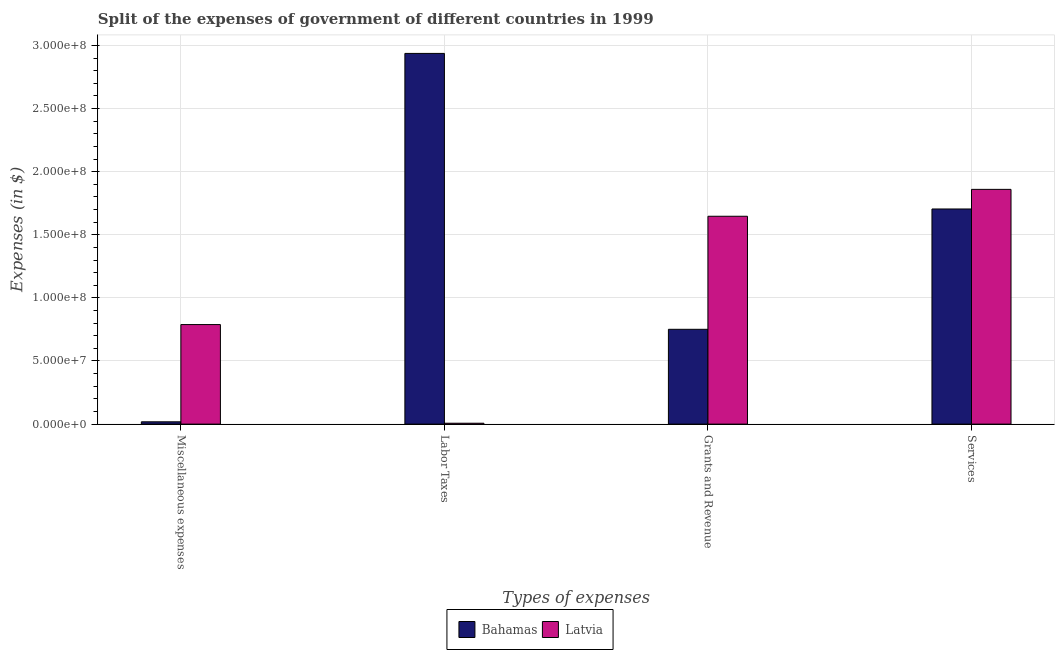How many groups of bars are there?
Ensure brevity in your answer.  4. Are the number of bars per tick equal to the number of legend labels?
Provide a short and direct response. Yes. What is the label of the 3rd group of bars from the left?
Provide a short and direct response. Grants and Revenue. What is the amount spent on labor taxes in Latvia?
Provide a succinct answer. 7.00e+05. Across all countries, what is the maximum amount spent on labor taxes?
Provide a short and direct response. 2.94e+08. Across all countries, what is the minimum amount spent on services?
Offer a very short reply. 1.70e+08. In which country was the amount spent on grants and revenue maximum?
Ensure brevity in your answer.  Latvia. In which country was the amount spent on miscellaneous expenses minimum?
Keep it short and to the point. Bahamas. What is the total amount spent on labor taxes in the graph?
Give a very brief answer. 2.94e+08. What is the difference between the amount spent on miscellaneous expenses in Bahamas and that in Latvia?
Provide a succinct answer. -7.70e+07. What is the difference between the amount spent on miscellaneous expenses in Latvia and the amount spent on labor taxes in Bahamas?
Ensure brevity in your answer.  -2.15e+08. What is the average amount spent on services per country?
Provide a succinct answer. 1.78e+08. What is the difference between the amount spent on miscellaneous expenses and amount spent on services in Latvia?
Your answer should be very brief. -1.07e+08. What is the ratio of the amount spent on grants and revenue in Latvia to that in Bahamas?
Your answer should be compact. 2.19. Is the difference between the amount spent on services in Bahamas and Latvia greater than the difference between the amount spent on grants and revenue in Bahamas and Latvia?
Offer a terse response. Yes. What is the difference between the highest and the second highest amount spent on miscellaneous expenses?
Provide a short and direct response. 7.70e+07. What is the difference between the highest and the lowest amount spent on labor taxes?
Give a very brief answer. 2.93e+08. What does the 1st bar from the left in Miscellaneous expenses represents?
Offer a very short reply. Bahamas. What does the 2nd bar from the right in Labor Taxes represents?
Ensure brevity in your answer.  Bahamas. Is it the case that in every country, the sum of the amount spent on miscellaneous expenses and amount spent on labor taxes is greater than the amount spent on grants and revenue?
Give a very brief answer. No. How many countries are there in the graph?
Provide a succinct answer. 2. Are the values on the major ticks of Y-axis written in scientific E-notation?
Your answer should be compact. Yes. Does the graph contain any zero values?
Your answer should be very brief. No. Does the graph contain grids?
Ensure brevity in your answer.  Yes. Where does the legend appear in the graph?
Ensure brevity in your answer.  Bottom center. How are the legend labels stacked?
Your answer should be compact. Horizontal. What is the title of the graph?
Provide a short and direct response. Split of the expenses of government of different countries in 1999. Does "Canada" appear as one of the legend labels in the graph?
Make the answer very short. No. What is the label or title of the X-axis?
Provide a succinct answer. Types of expenses. What is the label or title of the Y-axis?
Your response must be concise. Expenses (in $). What is the Expenses (in $) in Bahamas in Miscellaneous expenses?
Make the answer very short. 1.83e+06. What is the Expenses (in $) in Latvia in Miscellaneous expenses?
Keep it short and to the point. 7.89e+07. What is the Expenses (in $) in Bahamas in Labor Taxes?
Offer a terse response. 2.94e+08. What is the Expenses (in $) in Bahamas in Grants and Revenue?
Offer a terse response. 7.51e+07. What is the Expenses (in $) in Latvia in Grants and Revenue?
Your response must be concise. 1.65e+08. What is the Expenses (in $) in Bahamas in Services?
Offer a terse response. 1.70e+08. What is the Expenses (in $) of Latvia in Services?
Keep it short and to the point. 1.86e+08. Across all Types of expenses, what is the maximum Expenses (in $) of Bahamas?
Offer a very short reply. 2.94e+08. Across all Types of expenses, what is the maximum Expenses (in $) in Latvia?
Your response must be concise. 1.86e+08. Across all Types of expenses, what is the minimum Expenses (in $) of Bahamas?
Offer a terse response. 1.83e+06. What is the total Expenses (in $) of Bahamas in the graph?
Provide a short and direct response. 5.41e+08. What is the total Expenses (in $) of Latvia in the graph?
Offer a terse response. 4.30e+08. What is the difference between the Expenses (in $) in Bahamas in Miscellaneous expenses and that in Labor Taxes?
Your response must be concise. -2.92e+08. What is the difference between the Expenses (in $) of Latvia in Miscellaneous expenses and that in Labor Taxes?
Make the answer very short. 7.82e+07. What is the difference between the Expenses (in $) in Bahamas in Miscellaneous expenses and that in Grants and Revenue?
Make the answer very short. -7.33e+07. What is the difference between the Expenses (in $) in Latvia in Miscellaneous expenses and that in Grants and Revenue?
Offer a terse response. -8.58e+07. What is the difference between the Expenses (in $) of Bahamas in Miscellaneous expenses and that in Services?
Your response must be concise. -1.69e+08. What is the difference between the Expenses (in $) of Latvia in Miscellaneous expenses and that in Services?
Ensure brevity in your answer.  -1.07e+08. What is the difference between the Expenses (in $) in Bahamas in Labor Taxes and that in Grants and Revenue?
Your answer should be compact. 2.19e+08. What is the difference between the Expenses (in $) in Latvia in Labor Taxes and that in Grants and Revenue?
Offer a terse response. -1.64e+08. What is the difference between the Expenses (in $) in Bahamas in Labor Taxes and that in Services?
Your answer should be compact. 1.23e+08. What is the difference between the Expenses (in $) in Latvia in Labor Taxes and that in Services?
Ensure brevity in your answer.  -1.85e+08. What is the difference between the Expenses (in $) of Bahamas in Grants and Revenue and that in Services?
Provide a succinct answer. -9.53e+07. What is the difference between the Expenses (in $) in Latvia in Grants and Revenue and that in Services?
Your response must be concise. -2.13e+07. What is the difference between the Expenses (in $) in Bahamas in Miscellaneous expenses and the Expenses (in $) in Latvia in Labor Taxes?
Ensure brevity in your answer.  1.13e+06. What is the difference between the Expenses (in $) of Bahamas in Miscellaneous expenses and the Expenses (in $) of Latvia in Grants and Revenue?
Your response must be concise. -1.63e+08. What is the difference between the Expenses (in $) in Bahamas in Miscellaneous expenses and the Expenses (in $) in Latvia in Services?
Your response must be concise. -1.84e+08. What is the difference between the Expenses (in $) of Bahamas in Labor Taxes and the Expenses (in $) of Latvia in Grants and Revenue?
Provide a succinct answer. 1.29e+08. What is the difference between the Expenses (in $) of Bahamas in Labor Taxes and the Expenses (in $) of Latvia in Services?
Make the answer very short. 1.08e+08. What is the difference between the Expenses (in $) of Bahamas in Grants and Revenue and the Expenses (in $) of Latvia in Services?
Your answer should be compact. -1.11e+08. What is the average Expenses (in $) of Bahamas per Types of expenses?
Offer a terse response. 1.35e+08. What is the average Expenses (in $) in Latvia per Types of expenses?
Keep it short and to the point. 1.08e+08. What is the difference between the Expenses (in $) in Bahamas and Expenses (in $) in Latvia in Miscellaneous expenses?
Offer a very short reply. -7.70e+07. What is the difference between the Expenses (in $) in Bahamas and Expenses (in $) in Latvia in Labor Taxes?
Give a very brief answer. 2.93e+08. What is the difference between the Expenses (in $) of Bahamas and Expenses (in $) of Latvia in Grants and Revenue?
Your response must be concise. -8.96e+07. What is the difference between the Expenses (in $) in Bahamas and Expenses (in $) in Latvia in Services?
Offer a terse response. -1.55e+07. What is the ratio of the Expenses (in $) of Bahamas in Miscellaneous expenses to that in Labor Taxes?
Offer a very short reply. 0.01. What is the ratio of the Expenses (in $) in Latvia in Miscellaneous expenses to that in Labor Taxes?
Your answer should be compact. 112.66. What is the ratio of the Expenses (in $) in Bahamas in Miscellaneous expenses to that in Grants and Revenue?
Offer a terse response. 0.02. What is the ratio of the Expenses (in $) in Latvia in Miscellaneous expenses to that in Grants and Revenue?
Keep it short and to the point. 0.48. What is the ratio of the Expenses (in $) of Bahamas in Miscellaneous expenses to that in Services?
Provide a succinct answer. 0.01. What is the ratio of the Expenses (in $) in Latvia in Miscellaneous expenses to that in Services?
Provide a succinct answer. 0.42. What is the ratio of the Expenses (in $) in Bahamas in Labor Taxes to that in Grants and Revenue?
Offer a terse response. 3.91. What is the ratio of the Expenses (in $) in Latvia in Labor Taxes to that in Grants and Revenue?
Your response must be concise. 0. What is the ratio of the Expenses (in $) of Bahamas in Labor Taxes to that in Services?
Your answer should be very brief. 1.72. What is the ratio of the Expenses (in $) in Latvia in Labor Taxes to that in Services?
Make the answer very short. 0. What is the ratio of the Expenses (in $) in Bahamas in Grants and Revenue to that in Services?
Ensure brevity in your answer.  0.44. What is the ratio of the Expenses (in $) of Latvia in Grants and Revenue to that in Services?
Offer a very short reply. 0.89. What is the difference between the highest and the second highest Expenses (in $) in Bahamas?
Keep it short and to the point. 1.23e+08. What is the difference between the highest and the second highest Expenses (in $) in Latvia?
Offer a very short reply. 2.13e+07. What is the difference between the highest and the lowest Expenses (in $) of Bahamas?
Provide a short and direct response. 2.92e+08. What is the difference between the highest and the lowest Expenses (in $) of Latvia?
Make the answer very short. 1.85e+08. 